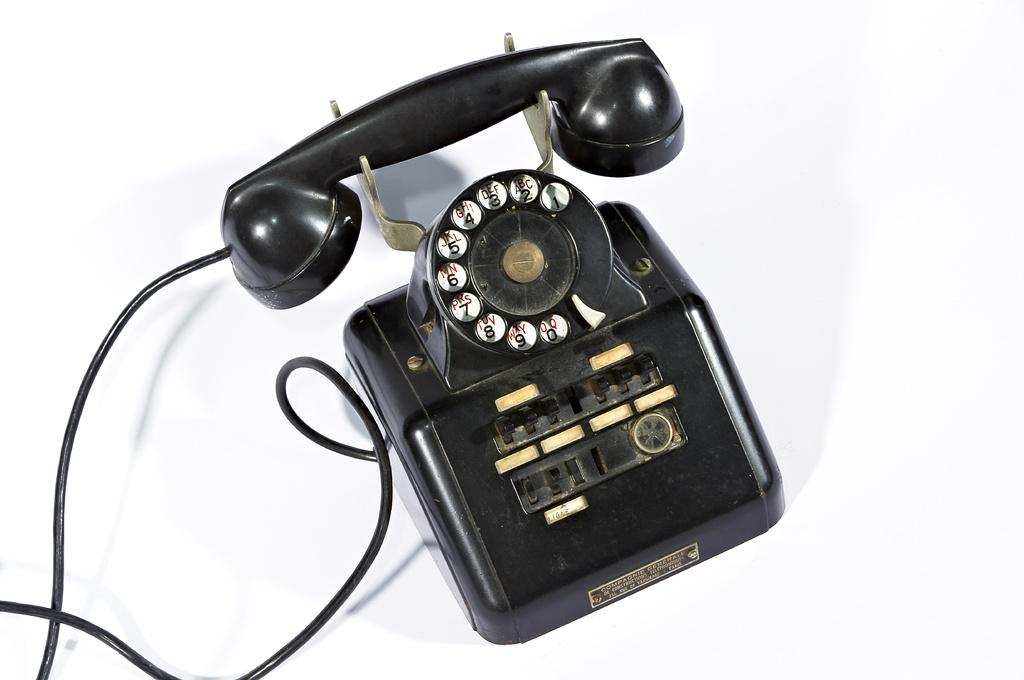<image>
Present a compact description of the photo's key features. A black telephone has a Ligne label below the dial pad. 